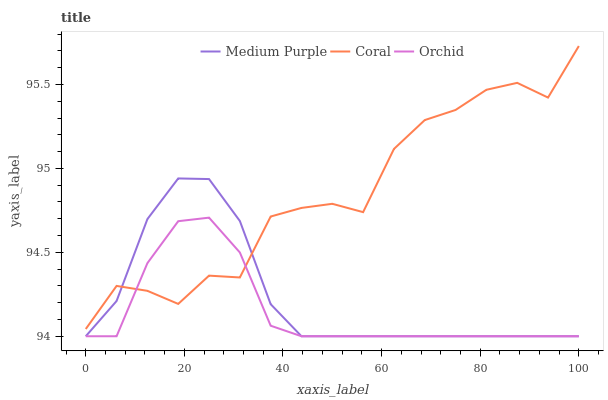Does Coral have the minimum area under the curve?
Answer yes or no. No. Does Orchid have the maximum area under the curve?
Answer yes or no. No. Is Coral the smoothest?
Answer yes or no. No. Is Orchid the roughest?
Answer yes or no. No. Does Coral have the lowest value?
Answer yes or no. No. Does Orchid have the highest value?
Answer yes or no. No. 